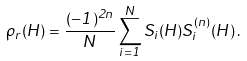<formula> <loc_0><loc_0><loc_500><loc_500>\rho _ { r } ( H ) = \frac { ( - 1 ) ^ { 2 n } } { N } \sum _ { i = 1 } ^ { N } S _ { i } ( H ) S _ { i } ^ { ( n ) } ( H ) \, .</formula> 